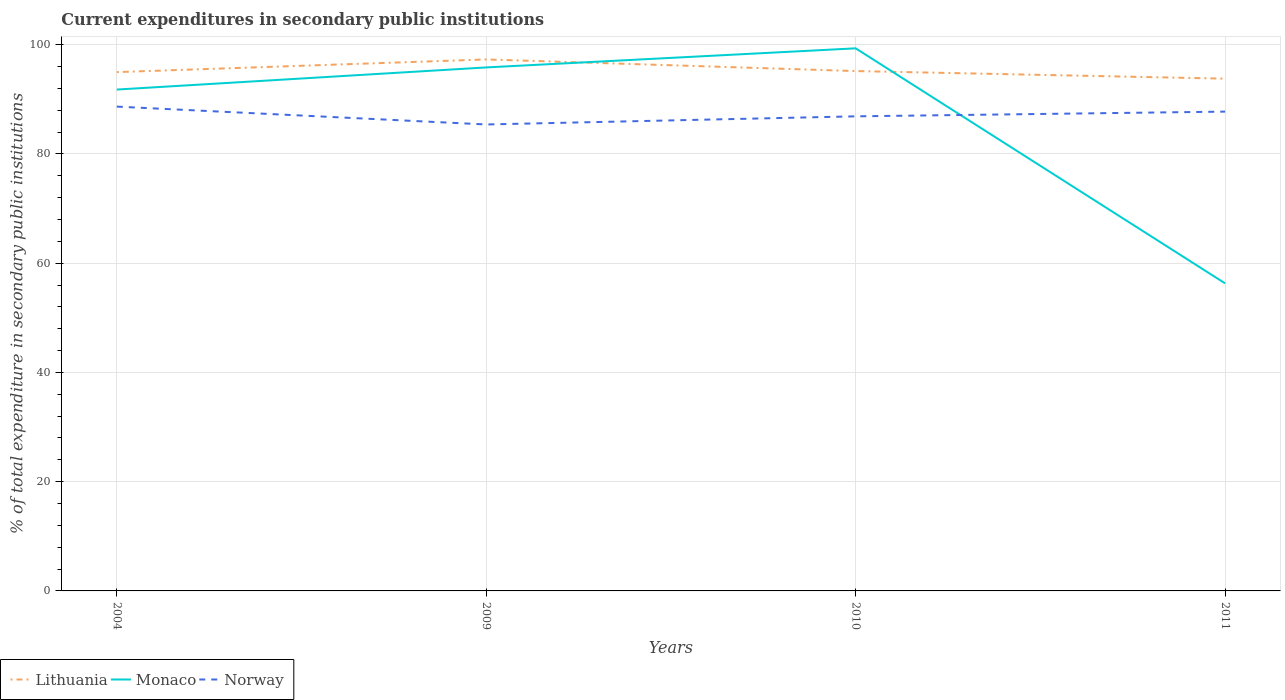How many different coloured lines are there?
Your response must be concise. 3. Across all years, what is the maximum current expenditures in secondary public institutions in Lithuania?
Your answer should be compact. 93.78. What is the total current expenditures in secondary public institutions in Lithuania in the graph?
Your response must be concise. -2.32. What is the difference between the highest and the second highest current expenditures in secondary public institutions in Monaco?
Make the answer very short. 43.03. Is the current expenditures in secondary public institutions in Monaco strictly greater than the current expenditures in secondary public institutions in Norway over the years?
Make the answer very short. No. Are the values on the major ticks of Y-axis written in scientific E-notation?
Offer a terse response. No. How are the legend labels stacked?
Your response must be concise. Horizontal. What is the title of the graph?
Give a very brief answer. Current expenditures in secondary public institutions. What is the label or title of the Y-axis?
Your response must be concise. % of total expenditure in secondary public institutions. What is the % of total expenditure in secondary public institutions in Lithuania in 2004?
Provide a succinct answer. 94.99. What is the % of total expenditure in secondary public institutions of Monaco in 2004?
Keep it short and to the point. 91.79. What is the % of total expenditure in secondary public institutions of Norway in 2004?
Offer a very short reply. 88.67. What is the % of total expenditure in secondary public institutions in Lithuania in 2009?
Offer a terse response. 97.3. What is the % of total expenditure in secondary public institutions of Monaco in 2009?
Keep it short and to the point. 95.84. What is the % of total expenditure in secondary public institutions in Norway in 2009?
Make the answer very short. 85.4. What is the % of total expenditure in secondary public institutions of Lithuania in 2010?
Your answer should be very brief. 95.18. What is the % of total expenditure in secondary public institutions in Monaco in 2010?
Offer a very short reply. 99.34. What is the % of total expenditure in secondary public institutions of Norway in 2010?
Provide a succinct answer. 86.89. What is the % of total expenditure in secondary public institutions of Lithuania in 2011?
Offer a very short reply. 93.78. What is the % of total expenditure in secondary public institutions of Monaco in 2011?
Give a very brief answer. 56.31. What is the % of total expenditure in secondary public institutions in Norway in 2011?
Your answer should be compact. 87.75. Across all years, what is the maximum % of total expenditure in secondary public institutions of Lithuania?
Offer a terse response. 97.3. Across all years, what is the maximum % of total expenditure in secondary public institutions in Monaco?
Your answer should be compact. 99.34. Across all years, what is the maximum % of total expenditure in secondary public institutions of Norway?
Offer a very short reply. 88.67. Across all years, what is the minimum % of total expenditure in secondary public institutions of Lithuania?
Your response must be concise. 93.78. Across all years, what is the minimum % of total expenditure in secondary public institutions in Monaco?
Ensure brevity in your answer.  56.31. Across all years, what is the minimum % of total expenditure in secondary public institutions in Norway?
Your answer should be very brief. 85.4. What is the total % of total expenditure in secondary public institutions of Lithuania in the graph?
Provide a short and direct response. 381.25. What is the total % of total expenditure in secondary public institutions of Monaco in the graph?
Keep it short and to the point. 343.28. What is the total % of total expenditure in secondary public institutions of Norway in the graph?
Give a very brief answer. 348.71. What is the difference between the % of total expenditure in secondary public institutions in Lithuania in 2004 and that in 2009?
Ensure brevity in your answer.  -2.32. What is the difference between the % of total expenditure in secondary public institutions in Monaco in 2004 and that in 2009?
Your response must be concise. -4.05. What is the difference between the % of total expenditure in secondary public institutions of Norway in 2004 and that in 2009?
Provide a succinct answer. 3.27. What is the difference between the % of total expenditure in secondary public institutions of Lithuania in 2004 and that in 2010?
Your response must be concise. -0.19. What is the difference between the % of total expenditure in secondary public institutions in Monaco in 2004 and that in 2010?
Offer a very short reply. -7.55. What is the difference between the % of total expenditure in secondary public institutions of Norway in 2004 and that in 2010?
Provide a short and direct response. 1.78. What is the difference between the % of total expenditure in secondary public institutions of Lithuania in 2004 and that in 2011?
Make the answer very short. 1.2. What is the difference between the % of total expenditure in secondary public institutions of Monaco in 2004 and that in 2011?
Give a very brief answer. 35.48. What is the difference between the % of total expenditure in secondary public institutions of Norway in 2004 and that in 2011?
Keep it short and to the point. 0.92. What is the difference between the % of total expenditure in secondary public institutions of Lithuania in 2009 and that in 2010?
Provide a short and direct response. 2.13. What is the difference between the % of total expenditure in secondary public institutions in Monaco in 2009 and that in 2010?
Give a very brief answer. -3.5. What is the difference between the % of total expenditure in secondary public institutions in Norway in 2009 and that in 2010?
Give a very brief answer. -1.49. What is the difference between the % of total expenditure in secondary public institutions of Lithuania in 2009 and that in 2011?
Ensure brevity in your answer.  3.52. What is the difference between the % of total expenditure in secondary public institutions in Monaco in 2009 and that in 2011?
Your answer should be compact. 39.53. What is the difference between the % of total expenditure in secondary public institutions in Norway in 2009 and that in 2011?
Ensure brevity in your answer.  -2.35. What is the difference between the % of total expenditure in secondary public institutions in Lithuania in 2010 and that in 2011?
Your answer should be very brief. 1.39. What is the difference between the % of total expenditure in secondary public institutions in Monaco in 2010 and that in 2011?
Make the answer very short. 43.03. What is the difference between the % of total expenditure in secondary public institutions of Norway in 2010 and that in 2011?
Your response must be concise. -0.87. What is the difference between the % of total expenditure in secondary public institutions of Lithuania in 2004 and the % of total expenditure in secondary public institutions of Monaco in 2009?
Your answer should be compact. -0.86. What is the difference between the % of total expenditure in secondary public institutions of Lithuania in 2004 and the % of total expenditure in secondary public institutions of Norway in 2009?
Make the answer very short. 9.59. What is the difference between the % of total expenditure in secondary public institutions of Monaco in 2004 and the % of total expenditure in secondary public institutions of Norway in 2009?
Make the answer very short. 6.39. What is the difference between the % of total expenditure in secondary public institutions of Lithuania in 2004 and the % of total expenditure in secondary public institutions of Monaco in 2010?
Make the answer very short. -4.35. What is the difference between the % of total expenditure in secondary public institutions in Lithuania in 2004 and the % of total expenditure in secondary public institutions in Norway in 2010?
Your answer should be very brief. 8.1. What is the difference between the % of total expenditure in secondary public institutions of Monaco in 2004 and the % of total expenditure in secondary public institutions of Norway in 2010?
Offer a very short reply. 4.9. What is the difference between the % of total expenditure in secondary public institutions of Lithuania in 2004 and the % of total expenditure in secondary public institutions of Monaco in 2011?
Offer a very short reply. 38.67. What is the difference between the % of total expenditure in secondary public institutions in Lithuania in 2004 and the % of total expenditure in secondary public institutions in Norway in 2011?
Offer a terse response. 7.23. What is the difference between the % of total expenditure in secondary public institutions of Monaco in 2004 and the % of total expenditure in secondary public institutions of Norway in 2011?
Offer a very short reply. 4.04. What is the difference between the % of total expenditure in secondary public institutions of Lithuania in 2009 and the % of total expenditure in secondary public institutions of Monaco in 2010?
Your response must be concise. -2.03. What is the difference between the % of total expenditure in secondary public institutions of Lithuania in 2009 and the % of total expenditure in secondary public institutions of Norway in 2010?
Give a very brief answer. 10.42. What is the difference between the % of total expenditure in secondary public institutions in Monaco in 2009 and the % of total expenditure in secondary public institutions in Norway in 2010?
Keep it short and to the point. 8.95. What is the difference between the % of total expenditure in secondary public institutions in Lithuania in 2009 and the % of total expenditure in secondary public institutions in Monaco in 2011?
Provide a short and direct response. 40.99. What is the difference between the % of total expenditure in secondary public institutions in Lithuania in 2009 and the % of total expenditure in secondary public institutions in Norway in 2011?
Your answer should be very brief. 9.55. What is the difference between the % of total expenditure in secondary public institutions of Monaco in 2009 and the % of total expenditure in secondary public institutions of Norway in 2011?
Make the answer very short. 8.09. What is the difference between the % of total expenditure in secondary public institutions in Lithuania in 2010 and the % of total expenditure in secondary public institutions in Monaco in 2011?
Ensure brevity in your answer.  38.87. What is the difference between the % of total expenditure in secondary public institutions in Lithuania in 2010 and the % of total expenditure in secondary public institutions in Norway in 2011?
Your answer should be compact. 7.42. What is the difference between the % of total expenditure in secondary public institutions in Monaco in 2010 and the % of total expenditure in secondary public institutions in Norway in 2011?
Offer a terse response. 11.59. What is the average % of total expenditure in secondary public institutions of Lithuania per year?
Provide a short and direct response. 95.31. What is the average % of total expenditure in secondary public institutions in Monaco per year?
Give a very brief answer. 85.82. What is the average % of total expenditure in secondary public institutions of Norway per year?
Your answer should be very brief. 87.18. In the year 2004, what is the difference between the % of total expenditure in secondary public institutions in Lithuania and % of total expenditure in secondary public institutions in Monaco?
Your response must be concise. 3.2. In the year 2004, what is the difference between the % of total expenditure in secondary public institutions in Lithuania and % of total expenditure in secondary public institutions in Norway?
Keep it short and to the point. 6.32. In the year 2004, what is the difference between the % of total expenditure in secondary public institutions in Monaco and % of total expenditure in secondary public institutions in Norway?
Give a very brief answer. 3.12. In the year 2009, what is the difference between the % of total expenditure in secondary public institutions of Lithuania and % of total expenditure in secondary public institutions of Monaco?
Make the answer very short. 1.46. In the year 2009, what is the difference between the % of total expenditure in secondary public institutions in Lithuania and % of total expenditure in secondary public institutions in Norway?
Offer a very short reply. 11.91. In the year 2009, what is the difference between the % of total expenditure in secondary public institutions of Monaco and % of total expenditure in secondary public institutions of Norway?
Make the answer very short. 10.44. In the year 2010, what is the difference between the % of total expenditure in secondary public institutions in Lithuania and % of total expenditure in secondary public institutions in Monaco?
Offer a terse response. -4.16. In the year 2010, what is the difference between the % of total expenditure in secondary public institutions of Lithuania and % of total expenditure in secondary public institutions of Norway?
Offer a very short reply. 8.29. In the year 2010, what is the difference between the % of total expenditure in secondary public institutions of Monaco and % of total expenditure in secondary public institutions of Norway?
Keep it short and to the point. 12.45. In the year 2011, what is the difference between the % of total expenditure in secondary public institutions in Lithuania and % of total expenditure in secondary public institutions in Monaco?
Provide a succinct answer. 37.47. In the year 2011, what is the difference between the % of total expenditure in secondary public institutions in Lithuania and % of total expenditure in secondary public institutions in Norway?
Your response must be concise. 6.03. In the year 2011, what is the difference between the % of total expenditure in secondary public institutions of Monaco and % of total expenditure in secondary public institutions of Norway?
Give a very brief answer. -31.44. What is the ratio of the % of total expenditure in secondary public institutions of Lithuania in 2004 to that in 2009?
Provide a short and direct response. 0.98. What is the ratio of the % of total expenditure in secondary public institutions in Monaco in 2004 to that in 2009?
Keep it short and to the point. 0.96. What is the ratio of the % of total expenditure in secondary public institutions in Norway in 2004 to that in 2009?
Provide a succinct answer. 1.04. What is the ratio of the % of total expenditure in secondary public institutions in Monaco in 2004 to that in 2010?
Provide a short and direct response. 0.92. What is the ratio of the % of total expenditure in secondary public institutions in Norway in 2004 to that in 2010?
Provide a short and direct response. 1.02. What is the ratio of the % of total expenditure in secondary public institutions in Lithuania in 2004 to that in 2011?
Your response must be concise. 1.01. What is the ratio of the % of total expenditure in secondary public institutions in Monaco in 2004 to that in 2011?
Make the answer very short. 1.63. What is the ratio of the % of total expenditure in secondary public institutions in Norway in 2004 to that in 2011?
Provide a short and direct response. 1.01. What is the ratio of the % of total expenditure in secondary public institutions of Lithuania in 2009 to that in 2010?
Make the answer very short. 1.02. What is the ratio of the % of total expenditure in secondary public institutions of Monaco in 2009 to that in 2010?
Your response must be concise. 0.96. What is the ratio of the % of total expenditure in secondary public institutions in Norway in 2009 to that in 2010?
Make the answer very short. 0.98. What is the ratio of the % of total expenditure in secondary public institutions in Lithuania in 2009 to that in 2011?
Offer a terse response. 1.04. What is the ratio of the % of total expenditure in secondary public institutions in Monaco in 2009 to that in 2011?
Ensure brevity in your answer.  1.7. What is the ratio of the % of total expenditure in secondary public institutions in Norway in 2009 to that in 2011?
Your answer should be compact. 0.97. What is the ratio of the % of total expenditure in secondary public institutions of Lithuania in 2010 to that in 2011?
Offer a terse response. 1.01. What is the ratio of the % of total expenditure in secondary public institutions of Monaco in 2010 to that in 2011?
Keep it short and to the point. 1.76. What is the ratio of the % of total expenditure in secondary public institutions in Norway in 2010 to that in 2011?
Offer a very short reply. 0.99. What is the difference between the highest and the second highest % of total expenditure in secondary public institutions in Lithuania?
Your answer should be compact. 2.13. What is the difference between the highest and the second highest % of total expenditure in secondary public institutions of Monaco?
Provide a succinct answer. 3.5. What is the difference between the highest and the second highest % of total expenditure in secondary public institutions in Norway?
Your answer should be compact. 0.92. What is the difference between the highest and the lowest % of total expenditure in secondary public institutions of Lithuania?
Ensure brevity in your answer.  3.52. What is the difference between the highest and the lowest % of total expenditure in secondary public institutions of Monaco?
Your answer should be compact. 43.03. What is the difference between the highest and the lowest % of total expenditure in secondary public institutions in Norway?
Your answer should be very brief. 3.27. 